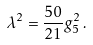Convert formula to latex. <formula><loc_0><loc_0><loc_500><loc_500>\lambda ^ { 2 } = \frac { 5 0 } { 2 1 } g _ { 5 } ^ { 2 } \, .</formula> 